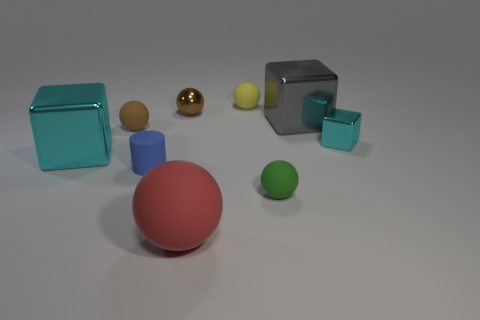Subtract all gray metallic cubes. How many cubes are left? 2 Subtract all purple cubes. How many brown spheres are left? 2 Add 1 big cyan metal spheres. How many objects exist? 10 Subtract all red balls. How many balls are left? 4 Subtract all yellow spheres. Subtract all brown blocks. How many spheres are left? 4 Subtract 1 yellow spheres. How many objects are left? 8 Subtract all cylinders. How many objects are left? 8 Subtract all small red metallic spheres. Subtract all small blue rubber objects. How many objects are left? 8 Add 7 small brown shiny spheres. How many small brown shiny spheres are left? 8 Add 1 large gray shiny things. How many large gray shiny things exist? 2 